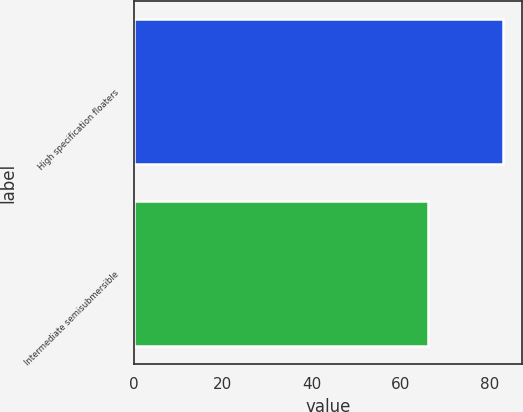Convert chart. <chart><loc_0><loc_0><loc_500><loc_500><bar_chart><fcel>High specification floaters<fcel>Intermediate semisubmersible<nl><fcel>83<fcel>66<nl></chart> 